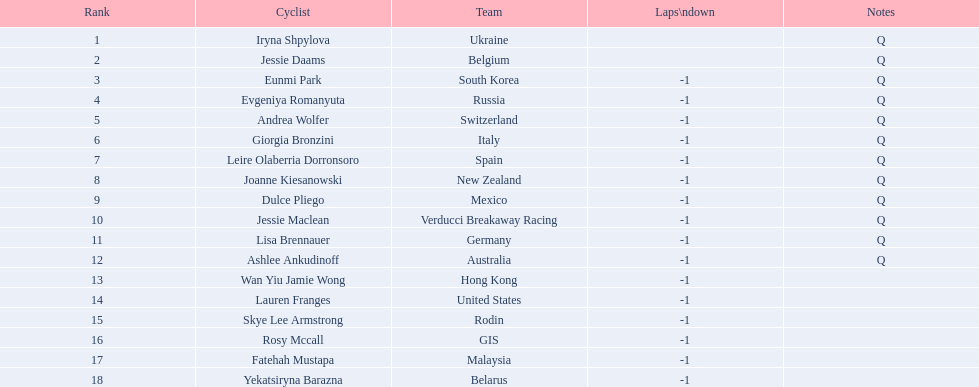Who joined the race? Iryna Shpylova, Jessie Daams, Eunmi Park, Evgeniya Romanyuta, Andrea Wolfer, Giorgia Bronzini, Leire Olaberria Dorronsoro, Joanne Kiesanowski, Dulce Pliego, Jessie Maclean, Lisa Brennauer, Ashlee Ankudinoff, Wan Yiu Jamie Wong, Lauren Franges, Skye Lee Armstrong, Rosy Mccall, Fatehah Mustapa, Yekatsiryna Barazna. Write the full table. {'header': ['Rank', 'Cyclist', 'Team', 'Laps\\ndown', 'Notes'], 'rows': [['1', 'Iryna Shpylova', 'Ukraine', '', 'Q'], ['2', 'Jessie Daams', 'Belgium', '', 'Q'], ['3', 'Eunmi Park', 'South Korea', '-1', 'Q'], ['4', 'Evgeniya Romanyuta', 'Russia', '-1', 'Q'], ['5', 'Andrea Wolfer', 'Switzerland', '-1', 'Q'], ['6', 'Giorgia Bronzini', 'Italy', '-1', 'Q'], ['7', 'Leire Olaberria Dorronsoro', 'Spain', '-1', 'Q'], ['8', 'Joanne Kiesanowski', 'New Zealand', '-1', 'Q'], ['9', 'Dulce Pliego', 'Mexico', '-1', 'Q'], ['10', 'Jessie Maclean', 'Verducci Breakaway Racing', '-1', 'Q'], ['11', 'Lisa Brennauer', 'Germany', '-1', 'Q'], ['12', 'Ashlee Ankudinoff', 'Australia', '-1', 'Q'], ['13', 'Wan Yiu Jamie Wong', 'Hong Kong', '-1', ''], ['14', 'Lauren Franges', 'United States', '-1', ''], ['15', 'Skye Lee Armstrong', 'Rodin', '-1', ''], ['16', 'Rosy Mccall', 'GIS', '-1', ''], ['17', 'Fatehah Mustapa', 'Malaysia', '-1', ''], ['18', 'Yekatsiryna Barazna', 'Belarus', '-1', '']]} Who attained the best standing in the race? Iryna Shpylova. 